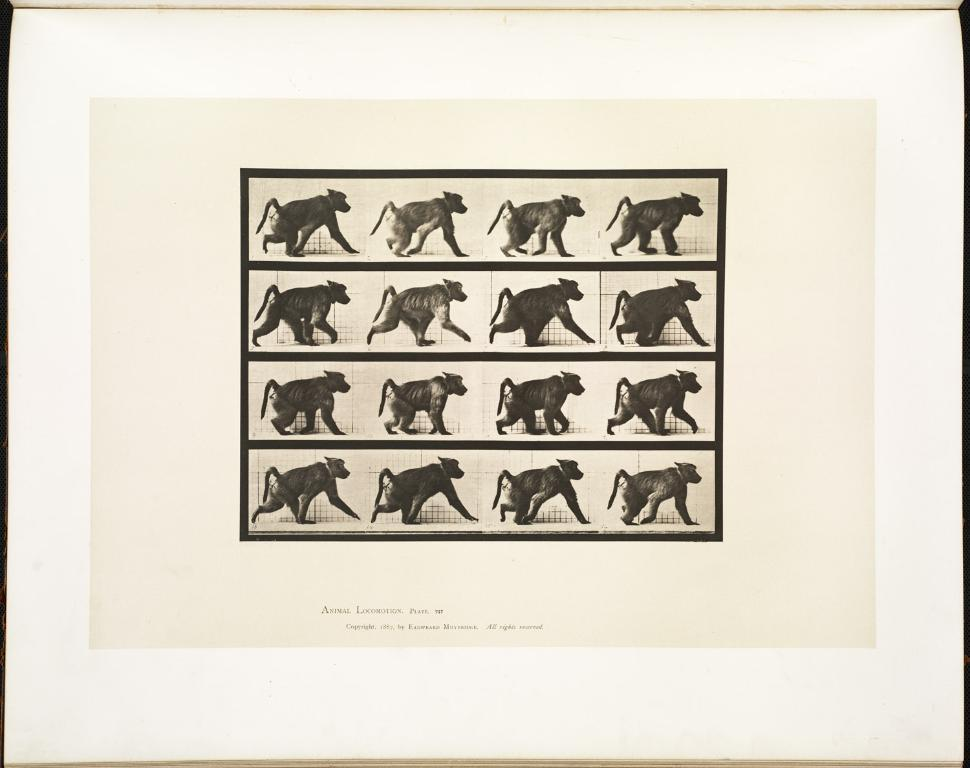What is present on the poster in the image? There is a poster in the image. What can be seen on the poster besides the poster itself? The poster contains an image of an animal. What type of hope can be seen on the poster in the image? There is no reference to hope in the image, as the poster only contains an image of an animal. What type of crush is the animal experiencing in the image? There is no indication of any emotions, including a crush, being experienced by the animal in the image. 